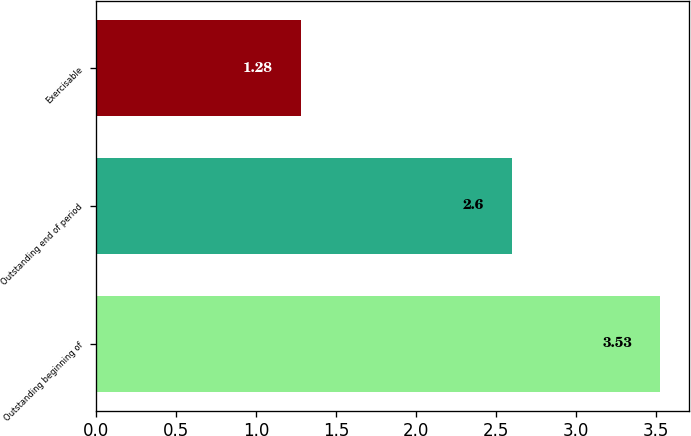Convert chart. <chart><loc_0><loc_0><loc_500><loc_500><bar_chart><fcel>Outstanding beginning of<fcel>Outstanding end of period<fcel>Exercisable<nl><fcel>3.53<fcel>2.6<fcel>1.28<nl></chart> 